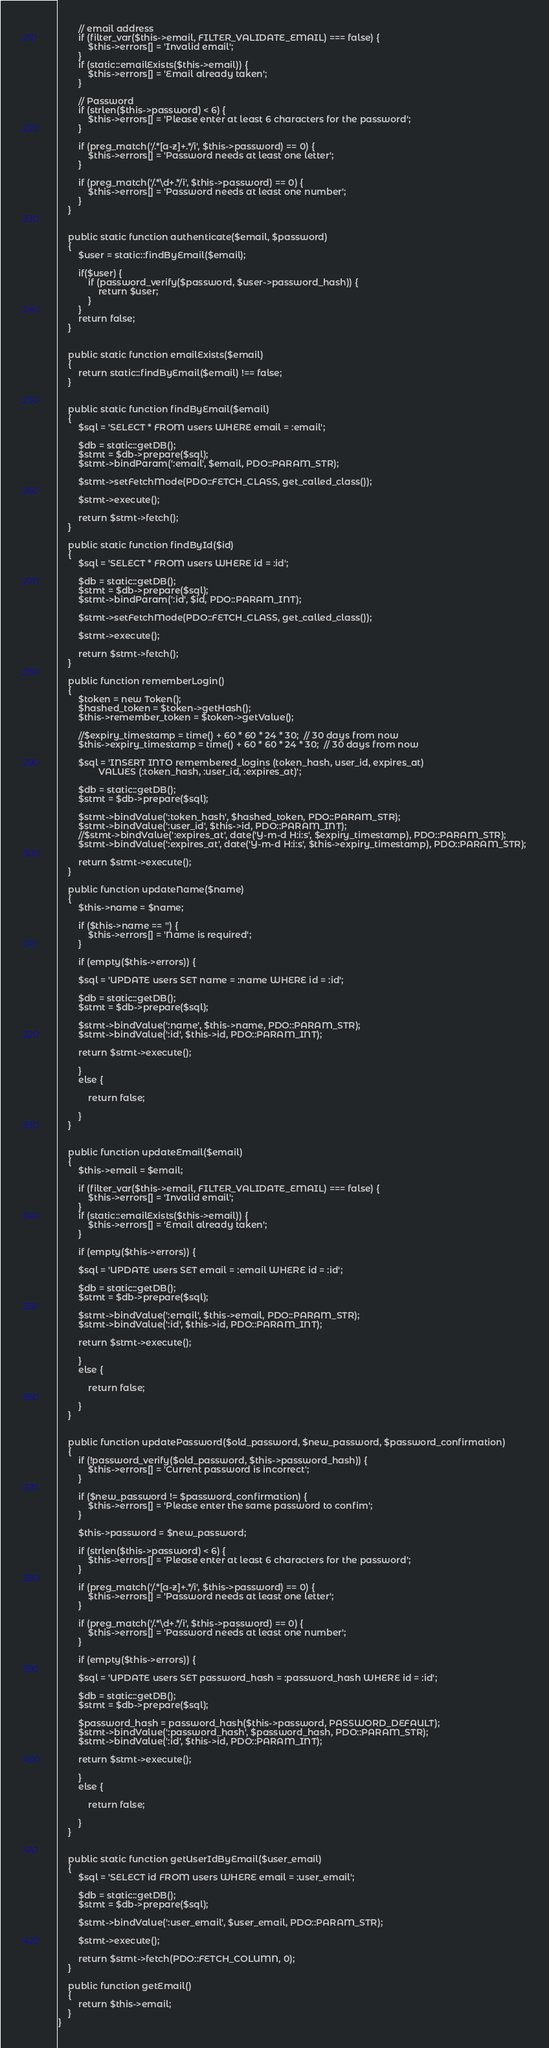<code> <loc_0><loc_0><loc_500><loc_500><_PHP_>
        // email address
        if (filter_var($this->email, FILTER_VALIDATE_EMAIL) === false) {
            $this->errors[] = 'Invalid email';
        }
        if (static::emailExists($this->email)) {
            $this->errors[] = 'Email already taken';
        }

        // Password
        if (strlen($this->password) < 6) {
            $this->errors[] = 'Please enter at least 6 characters for the password';
        }

        if (preg_match('/.*[a-z]+.*/i', $this->password) == 0) {
            $this->errors[] = 'Password needs at least one letter';
        }

        if (preg_match('/.*\d+.*/i', $this->password) == 0) {
            $this->errors[] = 'Password needs at least one number';
        }
    }


    public static function authenticate($email, $password)
    {
        $user = static::findByEmail($email);

        if($user) {
            if (password_verify($password, $user->password_hash)) {
                return $user;
            }
        }
        return false;
    }


    public static function emailExists($email)
    {
        return static::findByEmail($email) !== false;
    }


    public static function findByEmail($email)
    {
        $sql = 'SELECT * FROM users WHERE email = :email';

        $db = static::getDB();
        $stmt = $db->prepare($sql);
        $stmt->bindParam(':email', $email, PDO::PARAM_STR);

        $stmt->setFetchMode(PDO::FETCH_CLASS, get_called_class());

        $stmt->execute();

        return $stmt->fetch();
    }

    public static function findById($id)
    {
        $sql = 'SELECT * FROM users WHERE id = :id';

        $db = static::getDB();
        $stmt = $db->prepare($sql);
        $stmt->bindParam(':id', $id, PDO::PARAM_INT);

        $stmt->setFetchMode(PDO::FETCH_CLASS, get_called_class());

        $stmt->execute();

        return $stmt->fetch();
    }

    public function rememberLogin()
    {
        $token = new Token();
        $hashed_token = $token->getHash();
        $this->remember_token = $token->getValue();

        //$expiry_timestamp = time() + 60 * 60 * 24 * 30;  // 30 days from now
        $this->expiry_timestamp = time() + 60 * 60 * 24 * 30;  // 30 days from now

        $sql = 'INSERT INTO remembered_logins (token_hash, user_id, expires_at)
                VALUES (:token_hash, :user_id, :expires_at)';

        $db = static::getDB();
        $stmt = $db->prepare($sql);

        $stmt->bindValue(':token_hash', $hashed_token, PDO::PARAM_STR);
        $stmt->bindValue(':user_id', $this->id, PDO::PARAM_INT);
        //$stmt->bindValue(':expires_at', date('Y-m-d H:i:s', $expiry_timestamp), PDO::PARAM_STR);
        $stmt->bindValue(':expires_at', date('Y-m-d H:i:s', $this->expiry_timestamp), PDO::PARAM_STR);

        return $stmt->execute();
    }

    public function updateName($name) 
    {
        $this->name = $name;

        if ($this->name == '') {
            $this->errors[] = 'Name is required';
        }

        if (empty($this->errors)) {

        $sql = 'UPDATE users SET name = :name WHERE id = :id';

        $db = static::getDB();
        $stmt = $db->prepare($sql);

        $stmt->bindValue(':name', $this->name, PDO::PARAM_STR);
        $stmt->bindValue(':id', $this->id, PDO::PARAM_INT);

        return $stmt->execute();

        }
        else {

            return false;

        }
    }


    public function updateEmail($email) 
    {
        $this->email = $email;

        if (filter_var($this->email, FILTER_VALIDATE_EMAIL) === false) {
            $this->errors[] = 'Invalid email';
        }
        if (static::emailExists($this->email)) {
            $this->errors[] = 'Email already taken';
        }

        if (empty($this->errors)) {

        $sql = 'UPDATE users SET email = :email WHERE id = :id';

        $db = static::getDB();
        $stmt = $db->prepare($sql);

        $stmt->bindValue(':email', $this->email, PDO::PARAM_STR);
        $stmt->bindValue(':id', $this->id, PDO::PARAM_INT);

        return $stmt->execute();

        }
        else {

            return false;

        }
    }


    public function updatePassword($old_password, $new_password, $password_confirmation)
    {
        if (!password_verify($old_password, $this->password_hash)) {
            $this->errors[] = 'Current password is incorrect';
        }
        
        if ($new_password != $password_confirmation) {
            $this->errors[] = 'Please enter the same password to confim';
        }

        $this->password = $new_password;

        if (strlen($this->password) < 6) {
            $this->errors[] = 'Please enter at least 6 characters for the password';
        }

        if (preg_match('/.*[a-z]+.*/i', $this->password) == 0) {
            $this->errors[] = 'Password needs at least one letter';
        }

        if (preg_match('/.*\d+.*/i', $this->password) == 0) {
            $this->errors[] = 'Password needs at least one number';
        }

        if (empty($this->errors)) {

        $sql = 'UPDATE users SET password_hash = :password_hash WHERE id = :id';

        $db = static::getDB();
        $stmt = $db->prepare($sql);

        $password_hash = password_hash($this->password, PASSWORD_DEFAULT);
        $stmt->bindValue(':password_hash', $password_hash, PDO::PARAM_STR);
        $stmt->bindValue(':id', $this->id, PDO::PARAM_INT);

        return $stmt->execute();

        }
        else {

            return false;

        }
    }


    public static function getUserIdByEmail($user_email)
    {
        $sql = 'SELECT id FROM users WHERE email = :user_email';

        $db = static::getDB();
        $stmt = $db->prepare($sql);

        $stmt->bindValue(':user_email', $user_email, PDO::PARAM_STR);

        $stmt->execute();

        return $stmt->fetch(PDO::FETCH_COLUMN, 0);
    }

    public function getEmail()
    {
        return $this->email;
    }
}
</code> 